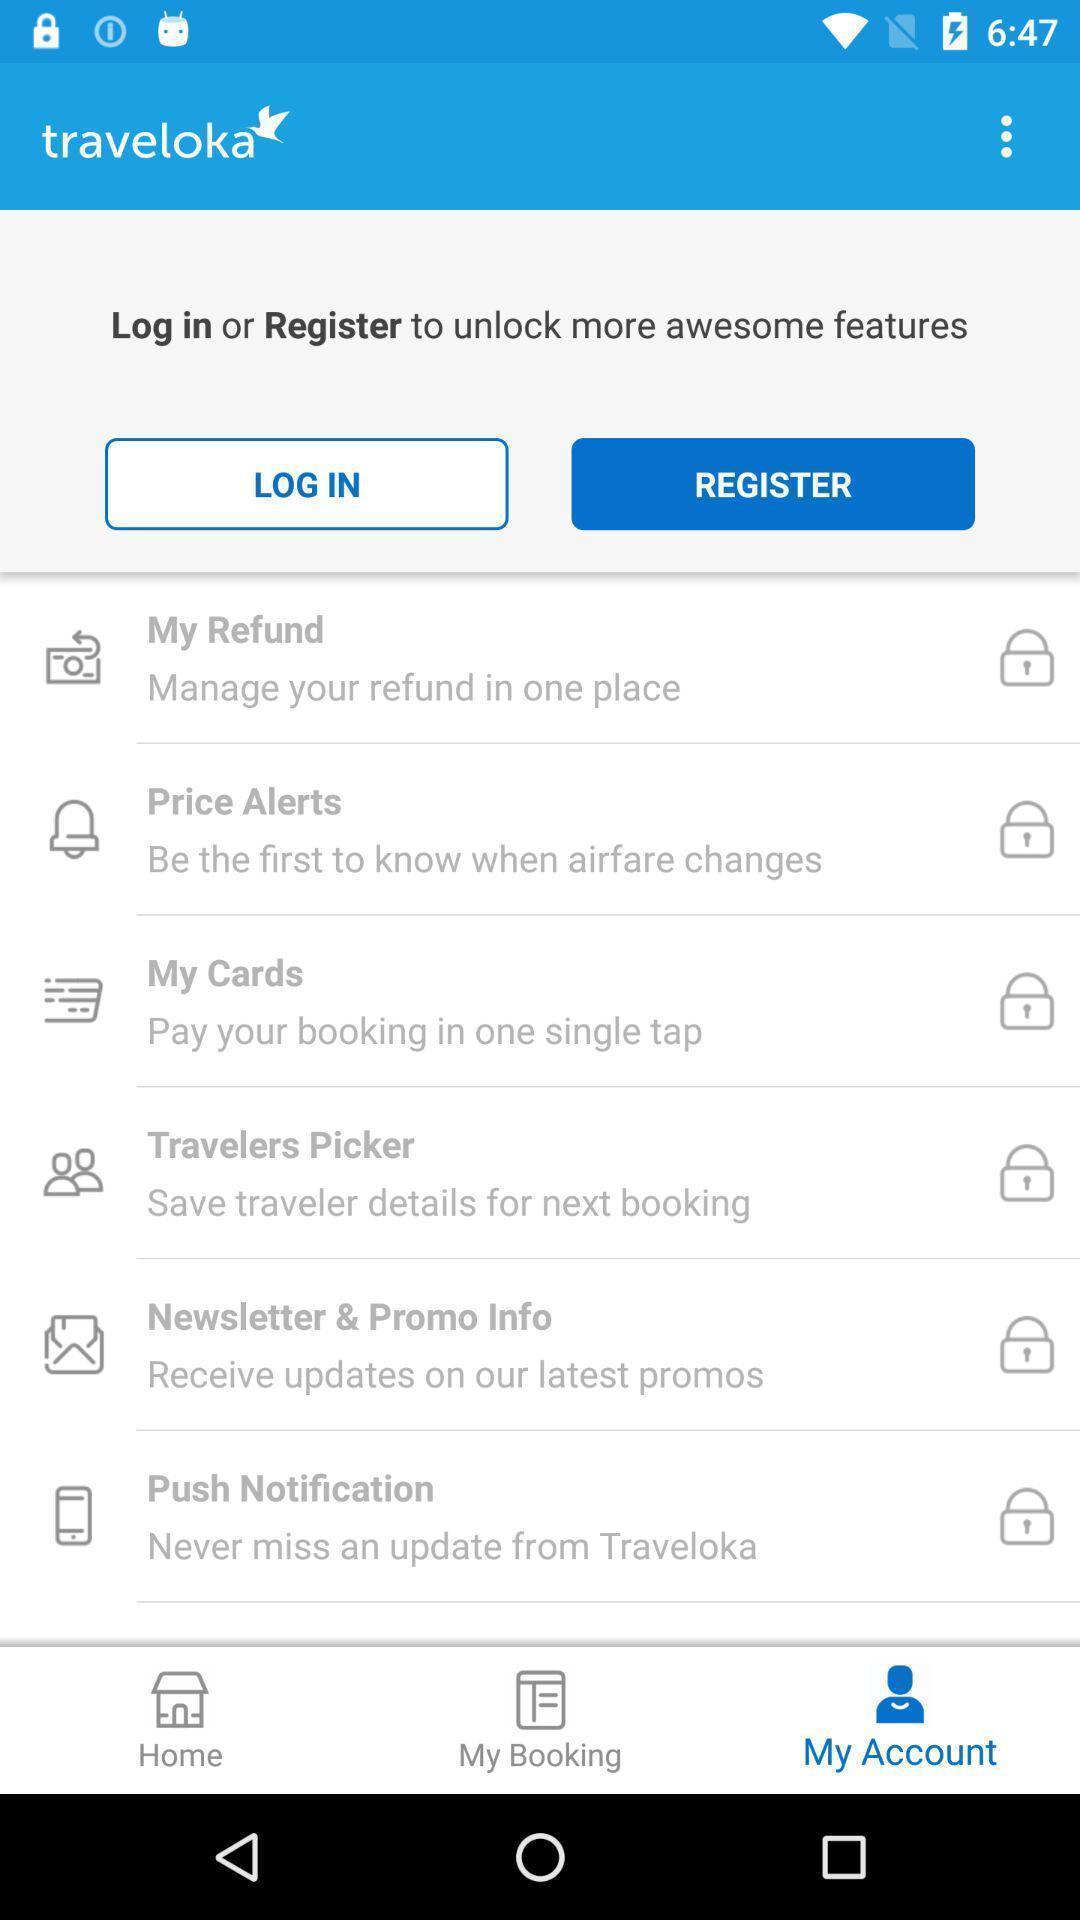What details can you identify in this image? Register page for travelling app. 